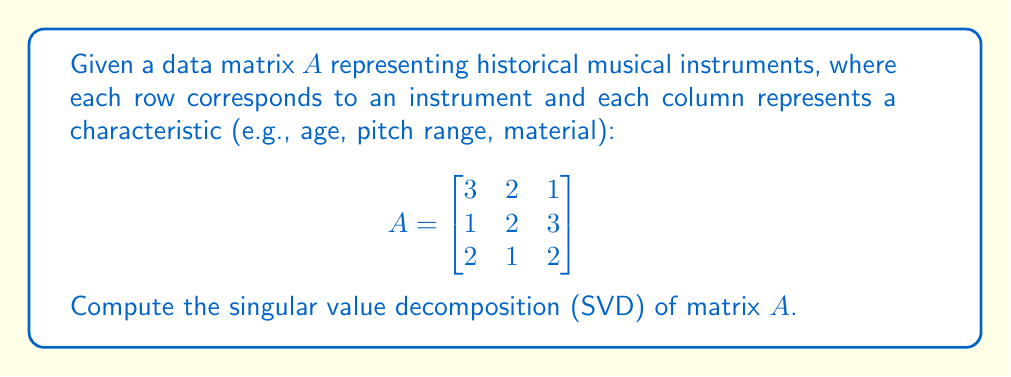Help me with this question. To compute the singular value decomposition of matrix $A$, we need to find matrices $U$, $\Sigma$, and $V^T$ such that $A = U\Sigma V^T$.

Step 1: Calculate $A^TA$ and $AA^T$
$$A^TA = \begin{bmatrix}
14 & 11 & 11 \\
11 & 9 & 9 \\
11 & 9 & 14
\end{bmatrix}$$

$$AA^T = \begin{bmatrix}
14 & 11 & 8 \\
11 & 14 & 11 \\
8 & 11 & 9
\end{bmatrix}$$

Step 2: Find eigenvalues of $A^TA$ (same as singular values squared)
Characteristic equation: $\det(A^TA - \lambda I) = 0$
$\lambda_1 \approx 33.97$, $\lambda_2 \approx 2.03$, $\lambda_3 = 1$

Step 3: Calculate singular values
$\sigma_1 \approx \sqrt{33.97} \approx 5.83$
$\sigma_2 \approx \sqrt{2.03} \approx 1.42$
$\sigma_3 = 1$

Step 4: Find right singular vectors (eigenvectors of $A^TA$)
$v_1 \approx [0.656, 0.521, 0.546]^T$
$v_2 \approx [-0.512, 0.840, -0.181]^T$
$v_3 \approx [0.555, 0.156, -0.817]^T$

Step 5: Find left singular vectors
$u_i = \frac{1}{\sigma_i}Av_i$ for $i = 1, 2, 3$
$u_1 \approx [0.480, 0.574, 0.663]^T$
$u_2 \approx [-0.786, 0.096, 0.611]^T$
$u_3 \approx [0.390, -0.813, 0.433]^T$

Step 6: Construct matrices $U$, $\Sigma$, and $V^T$
$$U \approx \begin{bmatrix}
0.480 & -0.786 & 0.390 \\
0.574 & 0.096 & -0.813 \\
0.663 & 0.611 & 0.433
\end{bmatrix}$$

$$\Sigma \approx \begin{bmatrix}
5.83 & 0 & 0 \\
0 & 1.42 & 0 \\
0 & 0 & 1
\end{bmatrix}$$

$$V^T \approx \begin{bmatrix}
0.656 & 0.521 & 0.546 \\
-0.512 & 0.840 & -0.181 \\
0.555 & 0.156 & -0.817
\end{bmatrix}$$
Answer: $A \approx U\Sigma V^T$, where:
$U \approx \begin{bmatrix}
0.480 & -0.786 & 0.390 \\
0.574 & 0.096 & -0.813 \\
0.663 & 0.611 & 0.433
\end{bmatrix}$,
$\Sigma \approx \begin{bmatrix}
5.83 & 0 & 0 \\
0 & 1.42 & 0 \\
0 & 0 & 1
\end{bmatrix}$,
$V^T \approx \begin{bmatrix}
0.656 & 0.521 & 0.546 \\
-0.512 & 0.840 & -0.181 \\
0.555 & 0.156 & -0.817
\end{bmatrix}$ 